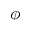Convert formula to latex. <formula><loc_0><loc_0><loc_500><loc_500>\phi</formula> 